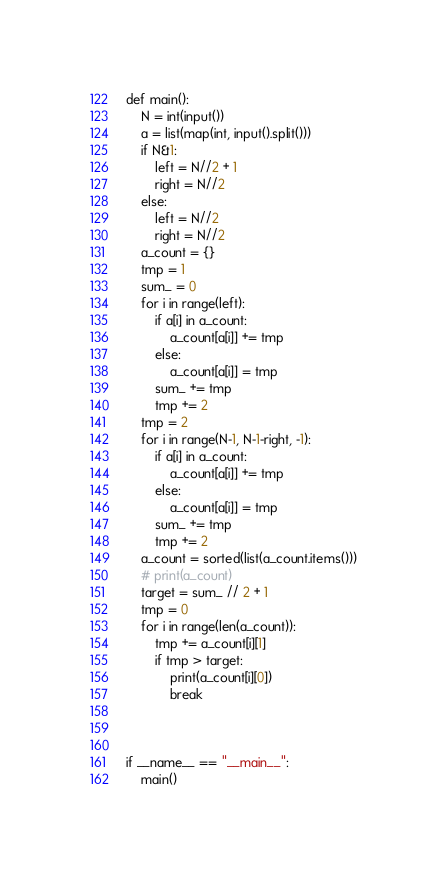<code> <loc_0><loc_0><loc_500><loc_500><_Python_>def main():
    N = int(input())
    a = list(map(int, input().split()))
    if N&1:
        left = N//2 + 1
        right = N//2
    else:
        left = N//2
        right = N//2
    a_count = {}
    tmp = 1
    sum_ = 0
    for i in range(left):
        if a[i] in a_count:
            a_count[a[i]] += tmp
        else:
            a_count[a[i]] = tmp
        sum_ += tmp
        tmp += 2
    tmp = 2
    for i in range(N-1, N-1-right, -1):
        if a[i] in a_count:
            a_count[a[i]] += tmp
        else:
            a_count[a[i]] = tmp
        sum_ += tmp
        tmp += 2
    a_count = sorted(list(a_count.items()))
    # print(a_count)
    target = sum_ // 2 + 1
    tmp = 0
    for i in range(len(a_count)):
        tmp += a_count[i][1]
        if tmp > target:
            print(a_count[i][0])
            break
    


if __name__ == "__main__":
    main()</code> 